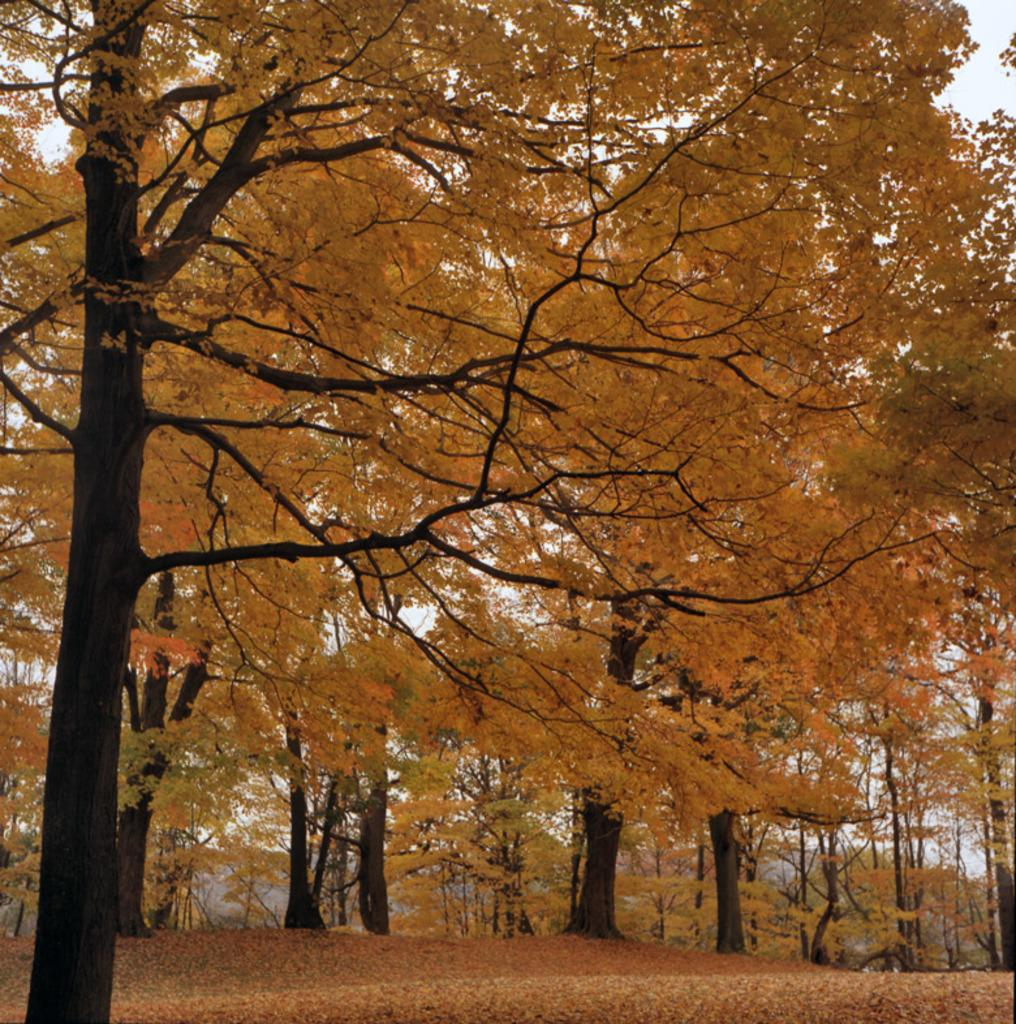What type of vegetation can be seen in the image? There are trees in the image. What is present on the surface at the bottom of the image? Leaves are present on the surface at the bottom of the image. What is visible at the top of the image? The sky is visible at the top of the image. What type of comfort does the mother provide during the operation in the image? There is no mother or operation present in the image; it features trees, leaves, and the sky. 